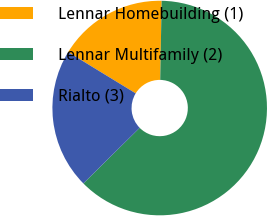Convert chart to OTSL. <chart><loc_0><loc_0><loc_500><loc_500><pie_chart><fcel>Lennar Homebuilding (1)<fcel>Lennar Multifamily (2)<fcel>Rialto (3)<nl><fcel>16.56%<fcel>62.31%<fcel>21.13%<nl></chart> 